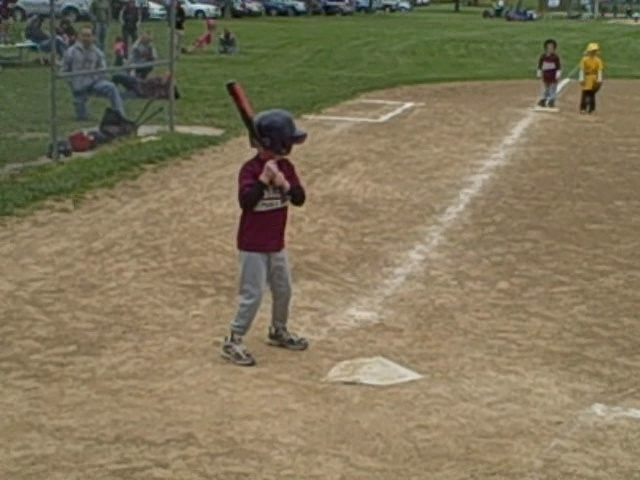Describe the objects in this image and their specific colors. I can see people in black, gray, and maroon tones, people in black, purple, and darkblue tones, car in black, gray, and purple tones, people in black and olive tones, and people in black, gray, and darkgreen tones in this image. 